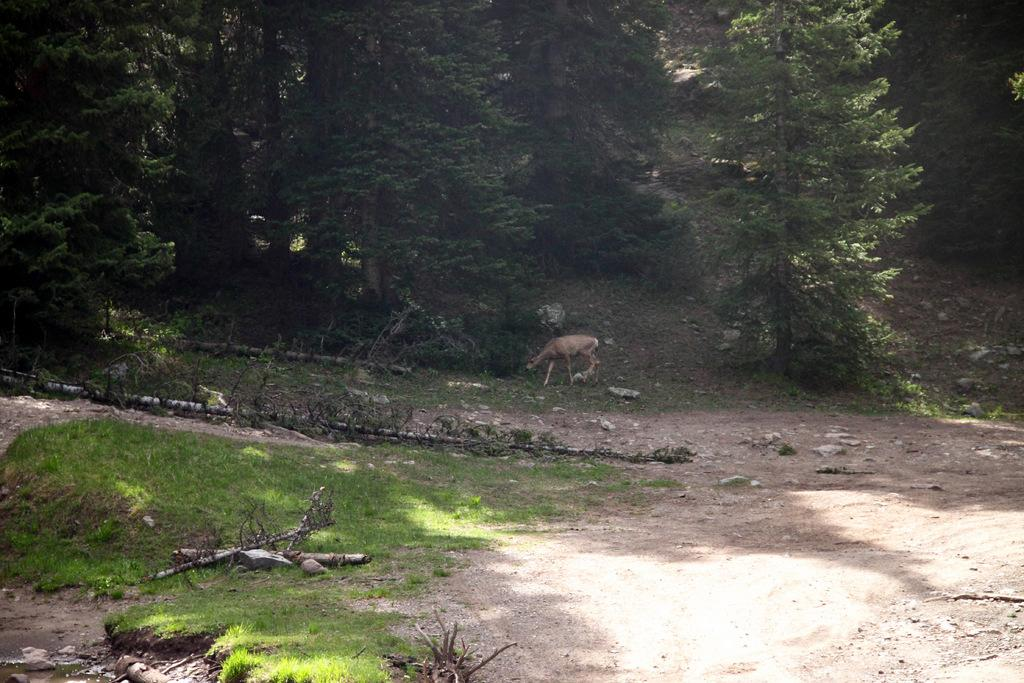What animal can be seen in the image? There is a deer in the image. What is the deer standing on? The deer is on grass in the image. What type of vegetation is visible in the image? There are trees in the image. What type of landscape is visible in the image? There are mountains in the image. Can you determine the time of day the image was taken? The image was likely taken during the day, as there is sufficient light to see the deer, grass, trees, and mountains clearly. What type of underwear is the deer wearing in the image? Deer do not wear underwear, and there is no underwear visible in the image. How does the deer maintain its grip on the grass in the image? Deer do not need to maintain a grip on the grass, as they have hooves that naturally provide traction. 